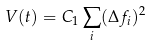Convert formula to latex. <formula><loc_0><loc_0><loc_500><loc_500>V ( t ) = C _ { 1 } \sum _ { i } ( \Delta f _ { i } ) ^ { 2 }</formula> 